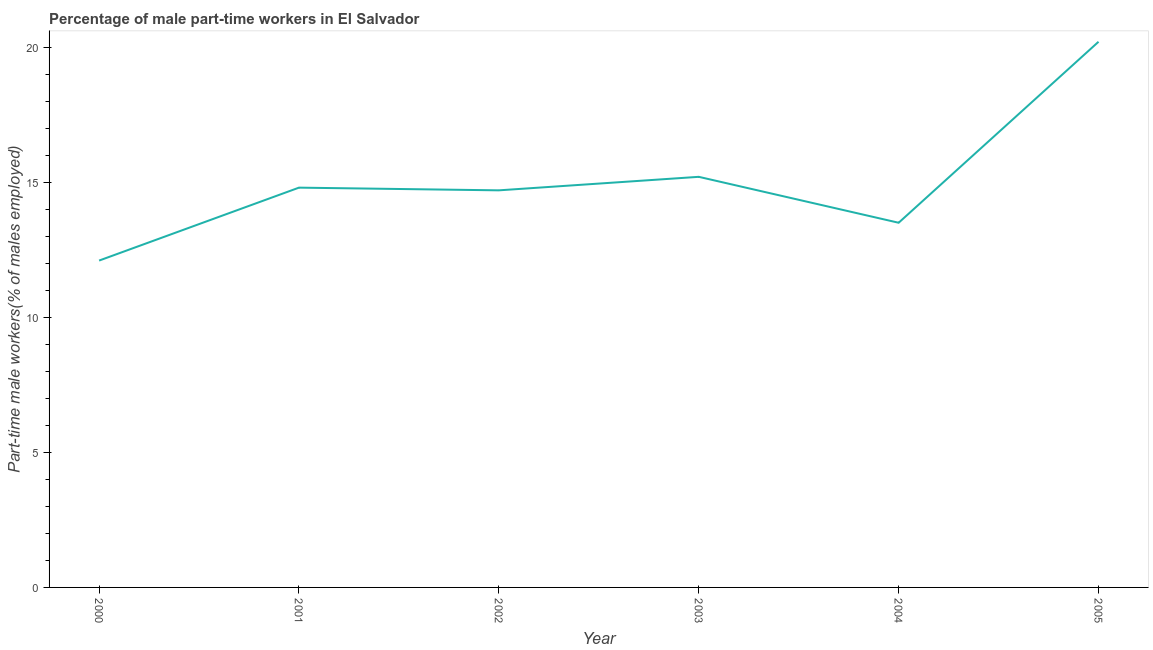What is the percentage of part-time male workers in 2000?
Offer a terse response. 12.1. Across all years, what is the maximum percentage of part-time male workers?
Offer a very short reply. 20.2. Across all years, what is the minimum percentage of part-time male workers?
Your response must be concise. 12.1. What is the sum of the percentage of part-time male workers?
Offer a terse response. 90.5. What is the difference between the percentage of part-time male workers in 2000 and 2004?
Offer a terse response. -1.4. What is the average percentage of part-time male workers per year?
Offer a very short reply. 15.08. What is the median percentage of part-time male workers?
Offer a terse response. 14.75. In how many years, is the percentage of part-time male workers greater than 14 %?
Provide a succinct answer. 4. What is the ratio of the percentage of part-time male workers in 2002 to that in 2003?
Provide a short and direct response. 0.97. Is the difference between the percentage of part-time male workers in 2002 and 2004 greater than the difference between any two years?
Provide a succinct answer. No. What is the difference between the highest and the second highest percentage of part-time male workers?
Give a very brief answer. 5. Is the sum of the percentage of part-time male workers in 2000 and 2002 greater than the maximum percentage of part-time male workers across all years?
Offer a terse response. Yes. What is the difference between the highest and the lowest percentage of part-time male workers?
Provide a short and direct response. 8.1. In how many years, is the percentage of part-time male workers greater than the average percentage of part-time male workers taken over all years?
Keep it short and to the point. 2. Does the percentage of part-time male workers monotonically increase over the years?
Your response must be concise. No. How many lines are there?
Give a very brief answer. 1. Does the graph contain grids?
Keep it short and to the point. No. What is the title of the graph?
Ensure brevity in your answer.  Percentage of male part-time workers in El Salvador. What is the label or title of the X-axis?
Make the answer very short. Year. What is the label or title of the Y-axis?
Ensure brevity in your answer.  Part-time male workers(% of males employed). What is the Part-time male workers(% of males employed) in 2000?
Your answer should be compact. 12.1. What is the Part-time male workers(% of males employed) in 2001?
Offer a very short reply. 14.8. What is the Part-time male workers(% of males employed) of 2002?
Provide a short and direct response. 14.7. What is the Part-time male workers(% of males employed) in 2003?
Offer a terse response. 15.2. What is the Part-time male workers(% of males employed) of 2005?
Provide a succinct answer. 20.2. What is the difference between the Part-time male workers(% of males employed) in 2000 and 2001?
Provide a succinct answer. -2.7. What is the difference between the Part-time male workers(% of males employed) in 2001 and 2002?
Make the answer very short. 0.1. What is the difference between the Part-time male workers(% of males employed) in 2001 and 2003?
Your response must be concise. -0.4. What is the difference between the Part-time male workers(% of males employed) in 2001 and 2004?
Give a very brief answer. 1.3. What is the difference between the Part-time male workers(% of males employed) in 2001 and 2005?
Your answer should be compact. -5.4. What is the difference between the Part-time male workers(% of males employed) in 2002 and 2004?
Your answer should be very brief. 1.2. What is the difference between the Part-time male workers(% of males employed) in 2003 and 2005?
Ensure brevity in your answer.  -5. What is the ratio of the Part-time male workers(% of males employed) in 2000 to that in 2001?
Offer a very short reply. 0.82. What is the ratio of the Part-time male workers(% of males employed) in 2000 to that in 2002?
Provide a short and direct response. 0.82. What is the ratio of the Part-time male workers(% of males employed) in 2000 to that in 2003?
Offer a terse response. 0.8. What is the ratio of the Part-time male workers(% of males employed) in 2000 to that in 2004?
Keep it short and to the point. 0.9. What is the ratio of the Part-time male workers(% of males employed) in 2000 to that in 2005?
Your answer should be compact. 0.6. What is the ratio of the Part-time male workers(% of males employed) in 2001 to that in 2004?
Provide a succinct answer. 1.1. What is the ratio of the Part-time male workers(% of males employed) in 2001 to that in 2005?
Provide a succinct answer. 0.73. What is the ratio of the Part-time male workers(% of males employed) in 2002 to that in 2004?
Offer a very short reply. 1.09. What is the ratio of the Part-time male workers(% of males employed) in 2002 to that in 2005?
Make the answer very short. 0.73. What is the ratio of the Part-time male workers(% of males employed) in 2003 to that in 2004?
Offer a very short reply. 1.13. What is the ratio of the Part-time male workers(% of males employed) in 2003 to that in 2005?
Ensure brevity in your answer.  0.75. What is the ratio of the Part-time male workers(% of males employed) in 2004 to that in 2005?
Ensure brevity in your answer.  0.67. 